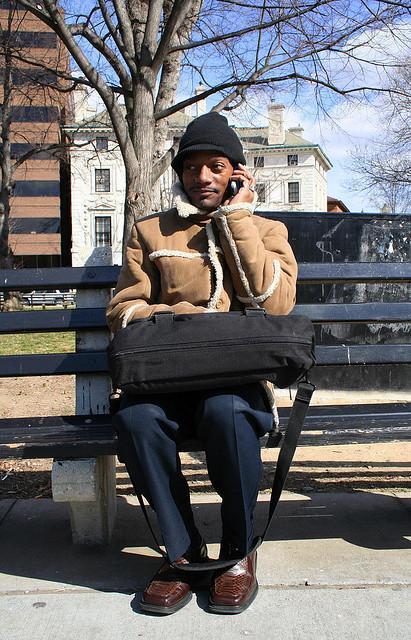How many handbags are in the picture?
Give a very brief answer. 1. How many benches are visible?
Give a very brief answer. 1. 